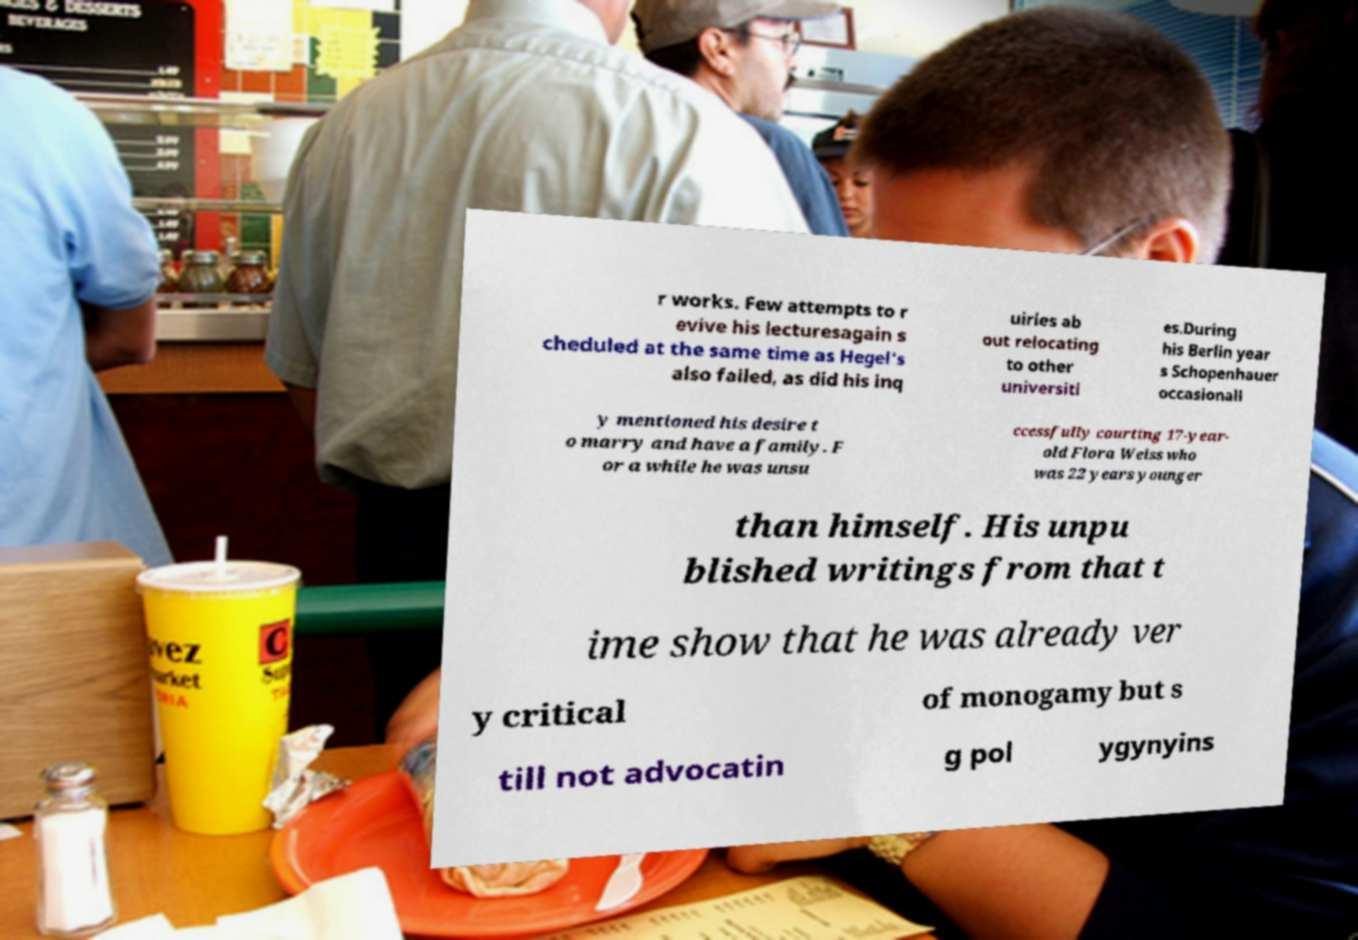Please identify and transcribe the text found in this image. r works. Few attempts to r evive his lecturesagain s cheduled at the same time as Hegel's also failed, as did his inq uiries ab out relocating to other universiti es.During his Berlin year s Schopenhauer occasionall y mentioned his desire t o marry and have a family. F or a while he was unsu ccessfully courting 17-year- old Flora Weiss who was 22 years younger than himself. His unpu blished writings from that t ime show that he was already ver y critical of monogamy but s till not advocatin g pol ygynyins 